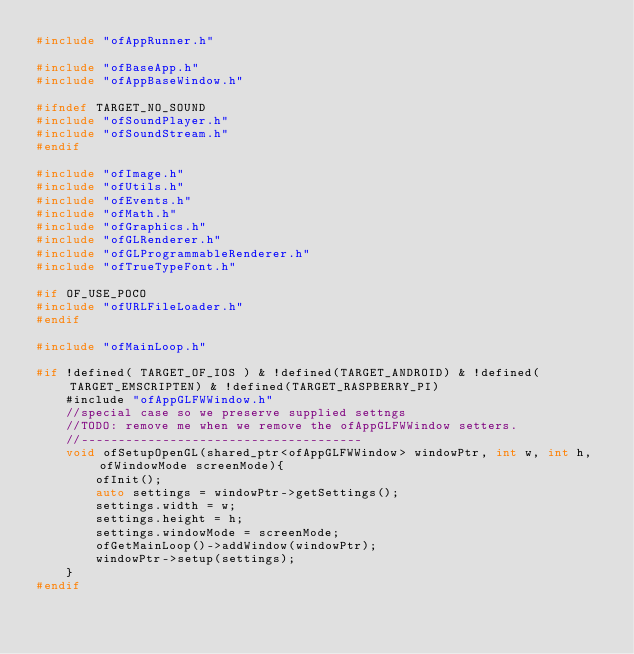<code> <loc_0><loc_0><loc_500><loc_500><_C++_>#include "ofAppRunner.h"

#include "ofBaseApp.h"
#include "ofAppBaseWindow.h"

#ifndef TARGET_NO_SOUND
#include "ofSoundPlayer.h"
#include "ofSoundStream.h"
#endif

#include "ofImage.h"
#include "ofUtils.h"
#include "ofEvents.h"
#include "ofMath.h"
#include "ofGraphics.h"
#include "ofGLRenderer.h"
#include "ofGLProgrammableRenderer.h"
#include "ofTrueTypeFont.h"

#if OF_USE_POCO
#include "ofURLFileLoader.h"
#endif

#include "ofMainLoop.h"

#if !defined( TARGET_OF_IOS ) & !defined(TARGET_ANDROID) & !defined(TARGET_EMSCRIPTEN) & !defined(TARGET_RASPBERRY_PI)
	#include "ofAppGLFWWindow.h"
	//special case so we preserve supplied settngs
	//TODO: remove me when we remove the ofAppGLFWWindow setters.
	//--------------------------------------
	void ofSetupOpenGL(shared_ptr<ofAppGLFWWindow> windowPtr, int w, int h, ofWindowMode screenMode){
		ofInit();
		auto settings = windowPtr->getSettings();
		settings.width = w;
		settings.height = h;
		settings.windowMode = screenMode;
		ofGetMainLoop()->addWindow(windowPtr);
		windowPtr->setup(settings);
	}
#endif
</code> 